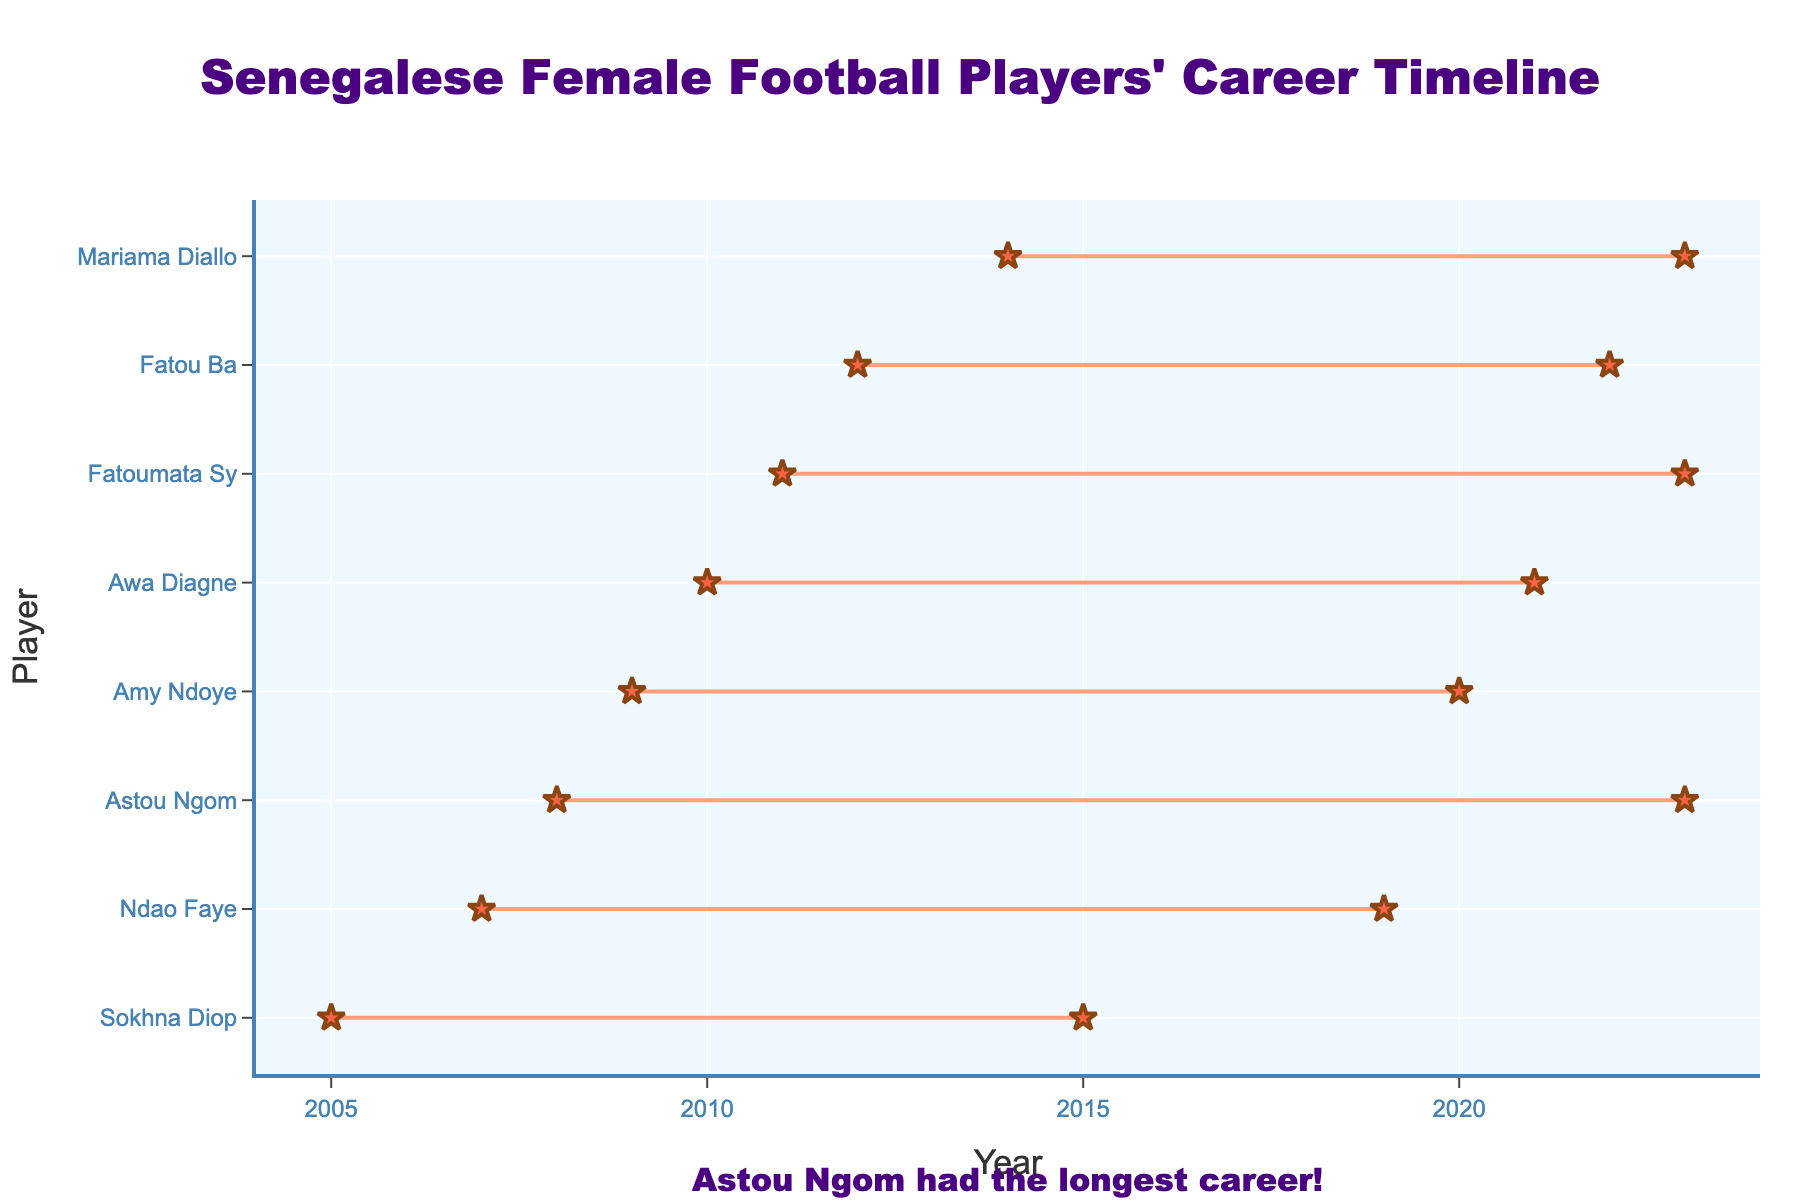What's the title of the plot? The title is usually located at the top center of the plot and in this case, it reads "Senegalese Female Football Players' Career Timeline".
Answer: "Senegalese Female Football Players' Career Timeline" What is the range of years displayed on the x-axis? By looking at the endpoints of the x-axis, we can see that they range from 2004 to 2024.
Answer: 2004 to 2024 Which player had the longest career? By examining the lengths of the lines representing each player's career, we can see that Astou Ngom has the longest line, indicating she had the longest career.
Answer: Astou Ngom Which player started their career the earliest? The earliest start year can be identified on the leftmost part of the x-axis, and the corresponding player is Sokhna Diop who started in 2005.
Answer: Sokhna Diop How many players retired in 2023? We can count the lines ending at 2023 on the x-axis. There are three players whose lines end at 2023: Astou Ngom, Mariama Diallo, and Fatoumata Sy.
Answer: 3 During which years did Awa Diagne's career span? By locating Awa Diagne’s name on the y-axis and seeing where her corresponding line starts and ends, we see it spans from 2010 to 2021.
Answer: From 2010 to 2021 Who had a career length of exactly 10 years? To find a career length of exactly 10 years, check the length of each player's line. Fatoumata Sy's career spans from 2011 to 2023, which is exactly 10 years.
Answer: Fatoumata Sy Compare the career lengths of Fatou Ba and Amy Ndoye. Who had a longer career? By visually comparing the lengths of the lines for Fatou Ba and Amy Ndoye, we see that Fatou Ba’s career (2012-2022) is 10 years, whereas Amy Ndoye's (2009-2020) is 11 years.
Answer: Amy Ndoye What is the average career length of all the players? To calculate this, we need to find the career lengths of each player, sum them up, and then divide by the total number of players. The career lengths are: Astou Ngom (15), Awa Diagne (11), Ndao Faye (12), Fatou Ba (10), Mariama Diallo (9), Sokhna Diop (10), Amy Ndoye (11), and Fatoumata Sy (12). Sum = 90 years; Number of players = 8. Average = 90/8.
Answer: 11.25 years Which player started their career immediately after Sokhna Diop retired? Sokhna Diop retired in 2015. The next earliest start year in the plot is 2010, which belongs to Awa Diagne, hence no player started immediately after Sokhna Diop.
Answer: None 